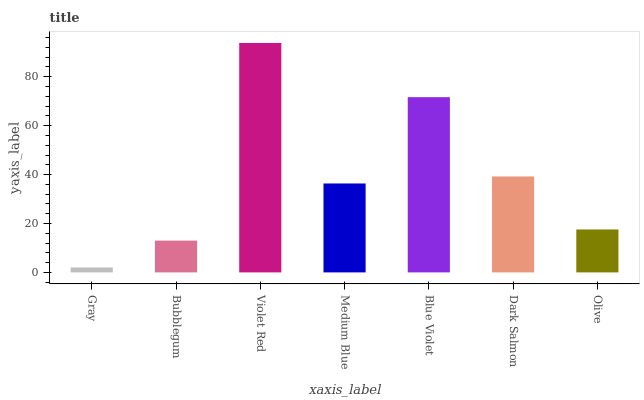Is Gray the minimum?
Answer yes or no. Yes. Is Violet Red the maximum?
Answer yes or no. Yes. Is Bubblegum the minimum?
Answer yes or no. No. Is Bubblegum the maximum?
Answer yes or no. No. Is Bubblegum greater than Gray?
Answer yes or no. Yes. Is Gray less than Bubblegum?
Answer yes or no. Yes. Is Gray greater than Bubblegum?
Answer yes or no. No. Is Bubblegum less than Gray?
Answer yes or no. No. Is Medium Blue the high median?
Answer yes or no. Yes. Is Medium Blue the low median?
Answer yes or no. Yes. Is Olive the high median?
Answer yes or no. No. Is Dark Salmon the low median?
Answer yes or no. No. 